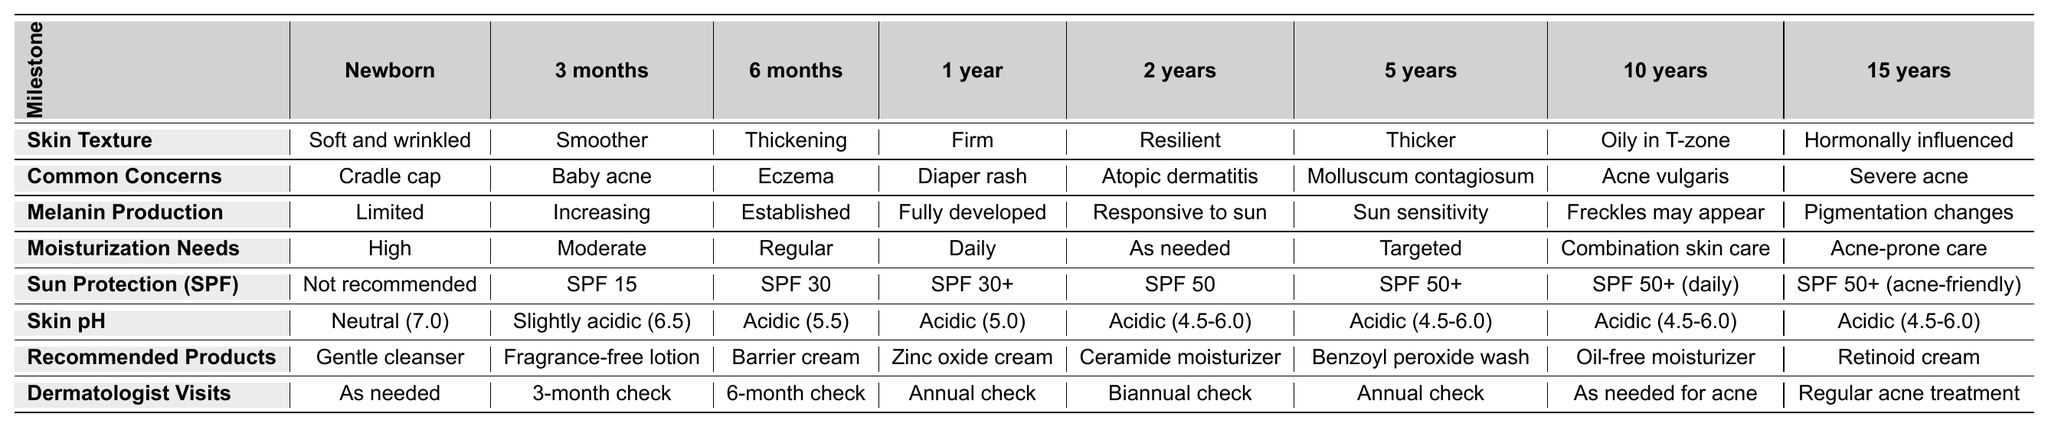What is the skin texture like for a newborn? According to the table, the skin texture for a newborn is "Soft and wrinkled."
Answer: Soft and wrinkled What common skin concern is associated with children at 6 months? The table indicates that eczema is a common concern for children at 6 months.
Answer: Eczema At what age is sun protection recommended to be SPF 50? The table shows that SPF 50 is recommended starting at 2 years of age.
Answer: 2 years How does melanin production change from newborn to 15 years? The table lists that melanin production goes from "Limited" at newborn, to "Increasing" at 3 months, "Established" at 6 months, "Fully developed" at 1 year, and then it becomes "Responsive to sun," "Sun sensitivity," "Freckles may appear," and finally "Pigmentation changes" at 15 years, showing a gradual increase and responsiveness to sunlight.
Answer: Increases progressively and becomes responsive to sun What is the difference in moisturization needs between a 1-year-old and a 5-year-old? The table shows that a 1-year-old has "Daily" moisturization needs, while a 5-year-old has "Targeted" needs. This suggests that as children age, their skin may require more specific care rather than regular daily moisturizing.
Answer: Daily vs. Targeted Is it true that a 10-year-old’s skin is oily in the T-zone? The table states that for a 10-year-old, the skin is described as "Oily in T-zone," so it is true.
Answer: True What are the recommended products for a 2-year-old? The table indicates that a ceramide moisturizer is recommended for a 2-year-old.
Answer: Ceramide moisturizer At what age does a child need to see a dermatologist most frequently? The table specifies that a child needs to see a dermatologist every 3 months at 3 months of age, implying this is the frequency for the youngest group.
Answer: 3 months How does the skin pH change from newborn to 2 years? The skin pH transitions from "Neutral (7.0)" at newborn, to "Slightly acidic (6.5)" at 3 months, and then to "Acidic (5.5)" at 6 months, finally reaching "Acidic (4.5-6.0)" at 2 years. This indicates a gradual move toward a more acidic skin environment as the child develops.
Answer: Becomes more acidic What are the dermatological check-up frequencies through childhood? The table outlines that newborns visit as needed; at 3 months, checks are every 3 months; at 6 months, every 6 months; at 1 year, annually; at 2 years, biannually; at 5 years, annually; at 10 years, as needed for acne; and at 15 years, regular acne treatment is advised.
Answer: Varies by age At what age do freckles typically start to appear? The table indicates that freckles may appear at age 10, suggesting this is when melanin production becomes more responsive, leading to pigmentation changes.
Answer: 10 years 